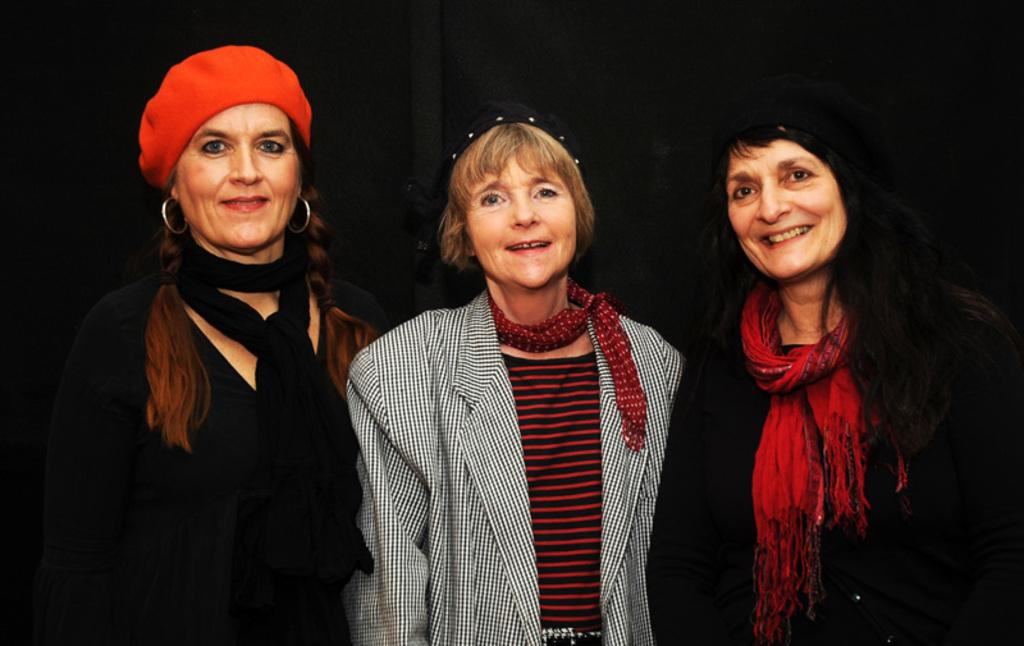How many people are in the image? There are three women in the image. What are the women doing in the image? The women are standing together. What type of bells can be heard ringing in the image? There are no bells present in the image, and therefore no sound can be heard. 